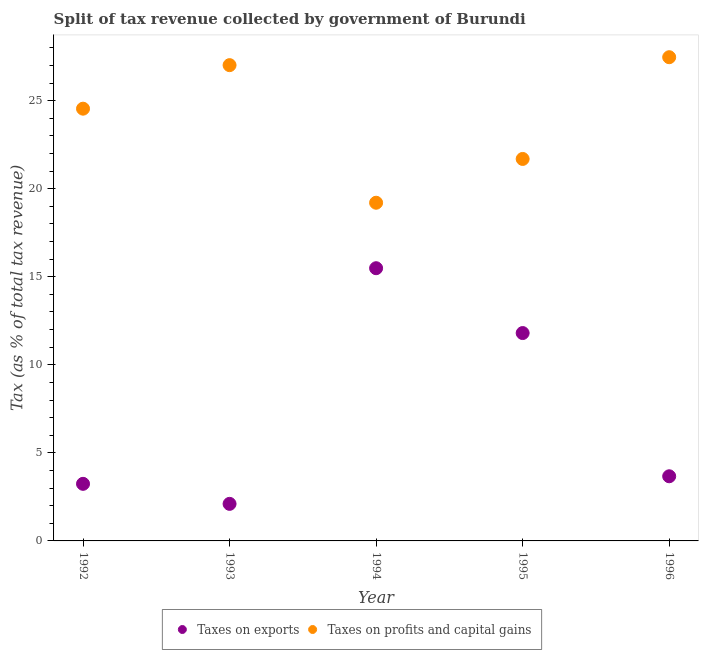How many different coloured dotlines are there?
Your response must be concise. 2. Is the number of dotlines equal to the number of legend labels?
Your response must be concise. Yes. What is the percentage of revenue obtained from taxes on profits and capital gains in 1993?
Offer a terse response. 27.02. Across all years, what is the maximum percentage of revenue obtained from taxes on exports?
Your answer should be very brief. 15.49. Across all years, what is the minimum percentage of revenue obtained from taxes on profits and capital gains?
Your response must be concise. 19.2. In which year was the percentage of revenue obtained from taxes on profits and capital gains maximum?
Provide a short and direct response. 1996. What is the total percentage of revenue obtained from taxes on profits and capital gains in the graph?
Your answer should be very brief. 119.92. What is the difference between the percentage of revenue obtained from taxes on exports in 1993 and that in 1994?
Your answer should be very brief. -13.38. What is the difference between the percentage of revenue obtained from taxes on profits and capital gains in 1994 and the percentage of revenue obtained from taxes on exports in 1993?
Keep it short and to the point. 17.1. What is the average percentage of revenue obtained from taxes on exports per year?
Give a very brief answer. 7.26. In the year 1993, what is the difference between the percentage of revenue obtained from taxes on exports and percentage of revenue obtained from taxes on profits and capital gains?
Offer a very short reply. -24.91. What is the ratio of the percentage of revenue obtained from taxes on exports in 1992 to that in 1993?
Offer a terse response. 1.54. Is the difference between the percentage of revenue obtained from taxes on exports in 1993 and 1994 greater than the difference between the percentage of revenue obtained from taxes on profits and capital gains in 1993 and 1994?
Make the answer very short. No. What is the difference between the highest and the second highest percentage of revenue obtained from taxes on exports?
Offer a very short reply. 3.68. What is the difference between the highest and the lowest percentage of revenue obtained from taxes on exports?
Make the answer very short. 13.38. Is the sum of the percentage of revenue obtained from taxes on profits and capital gains in 1993 and 1996 greater than the maximum percentage of revenue obtained from taxes on exports across all years?
Give a very brief answer. Yes. Does the percentage of revenue obtained from taxes on exports monotonically increase over the years?
Keep it short and to the point. No. Are the values on the major ticks of Y-axis written in scientific E-notation?
Your response must be concise. No. Does the graph contain any zero values?
Offer a terse response. No. Where does the legend appear in the graph?
Offer a terse response. Bottom center. How many legend labels are there?
Offer a very short reply. 2. How are the legend labels stacked?
Keep it short and to the point. Horizontal. What is the title of the graph?
Your answer should be compact. Split of tax revenue collected by government of Burundi. Does "Domestic liabilities" appear as one of the legend labels in the graph?
Keep it short and to the point. No. What is the label or title of the X-axis?
Your response must be concise. Year. What is the label or title of the Y-axis?
Provide a succinct answer. Tax (as % of total tax revenue). What is the Tax (as % of total tax revenue) in Taxes on exports in 1992?
Offer a very short reply. 3.24. What is the Tax (as % of total tax revenue) of Taxes on profits and capital gains in 1992?
Keep it short and to the point. 24.54. What is the Tax (as % of total tax revenue) of Taxes on exports in 1993?
Offer a very short reply. 2.1. What is the Tax (as % of total tax revenue) of Taxes on profits and capital gains in 1993?
Offer a very short reply. 27.02. What is the Tax (as % of total tax revenue) of Taxes on exports in 1994?
Your response must be concise. 15.49. What is the Tax (as % of total tax revenue) in Taxes on profits and capital gains in 1994?
Offer a terse response. 19.2. What is the Tax (as % of total tax revenue) in Taxes on exports in 1995?
Provide a succinct answer. 11.8. What is the Tax (as % of total tax revenue) of Taxes on profits and capital gains in 1995?
Keep it short and to the point. 21.69. What is the Tax (as % of total tax revenue) in Taxes on exports in 1996?
Offer a very short reply. 3.67. What is the Tax (as % of total tax revenue) in Taxes on profits and capital gains in 1996?
Ensure brevity in your answer.  27.47. Across all years, what is the maximum Tax (as % of total tax revenue) of Taxes on exports?
Provide a short and direct response. 15.49. Across all years, what is the maximum Tax (as % of total tax revenue) of Taxes on profits and capital gains?
Your answer should be compact. 27.47. Across all years, what is the minimum Tax (as % of total tax revenue) in Taxes on exports?
Your answer should be compact. 2.1. Across all years, what is the minimum Tax (as % of total tax revenue) of Taxes on profits and capital gains?
Offer a very short reply. 19.2. What is the total Tax (as % of total tax revenue) of Taxes on exports in the graph?
Your answer should be compact. 36.31. What is the total Tax (as % of total tax revenue) of Taxes on profits and capital gains in the graph?
Your answer should be compact. 119.92. What is the difference between the Tax (as % of total tax revenue) in Taxes on exports in 1992 and that in 1993?
Your response must be concise. 1.14. What is the difference between the Tax (as % of total tax revenue) of Taxes on profits and capital gains in 1992 and that in 1993?
Ensure brevity in your answer.  -2.47. What is the difference between the Tax (as % of total tax revenue) in Taxes on exports in 1992 and that in 1994?
Offer a terse response. -12.24. What is the difference between the Tax (as % of total tax revenue) of Taxes on profits and capital gains in 1992 and that in 1994?
Offer a terse response. 5.34. What is the difference between the Tax (as % of total tax revenue) in Taxes on exports in 1992 and that in 1995?
Your answer should be very brief. -8.56. What is the difference between the Tax (as % of total tax revenue) of Taxes on profits and capital gains in 1992 and that in 1995?
Offer a very short reply. 2.85. What is the difference between the Tax (as % of total tax revenue) of Taxes on exports in 1992 and that in 1996?
Keep it short and to the point. -0.43. What is the difference between the Tax (as % of total tax revenue) of Taxes on profits and capital gains in 1992 and that in 1996?
Provide a succinct answer. -2.92. What is the difference between the Tax (as % of total tax revenue) in Taxes on exports in 1993 and that in 1994?
Offer a terse response. -13.38. What is the difference between the Tax (as % of total tax revenue) of Taxes on profits and capital gains in 1993 and that in 1994?
Give a very brief answer. 7.81. What is the difference between the Tax (as % of total tax revenue) of Taxes on exports in 1993 and that in 1995?
Keep it short and to the point. -9.7. What is the difference between the Tax (as % of total tax revenue) in Taxes on profits and capital gains in 1993 and that in 1995?
Your answer should be compact. 5.33. What is the difference between the Tax (as % of total tax revenue) in Taxes on exports in 1993 and that in 1996?
Your answer should be very brief. -1.57. What is the difference between the Tax (as % of total tax revenue) of Taxes on profits and capital gains in 1993 and that in 1996?
Keep it short and to the point. -0.45. What is the difference between the Tax (as % of total tax revenue) of Taxes on exports in 1994 and that in 1995?
Your response must be concise. 3.68. What is the difference between the Tax (as % of total tax revenue) of Taxes on profits and capital gains in 1994 and that in 1995?
Make the answer very short. -2.49. What is the difference between the Tax (as % of total tax revenue) in Taxes on exports in 1994 and that in 1996?
Your answer should be compact. 11.81. What is the difference between the Tax (as % of total tax revenue) in Taxes on profits and capital gains in 1994 and that in 1996?
Your answer should be compact. -8.26. What is the difference between the Tax (as % of total tax revenue) in Taxes on exports in 1995 and that in 1996?
Keep it short and to the point. 8.13. What is the difference between the Tax (as % of total tax revenue) in Taxes on profits and capital gains in 1995 and that in 1996?
Provide a succinct answer. -5.78. What is the difference between the Tax (as % of total tax revenue) of Taxes on exports in 1992 and the Tax (as % of total tax revenue) of Taxes on profits and capital gains in 1993?
Your answer should be compact. -23.78. What is the difference between the Tax (as % of total tax revenue) of Taxes on exports in 1992 and the Tax (as % of total tax revenue) of Taxes on profits and capital gains in 1994?
Provide a succinct answer. -15.96. What is the difference between the Tax (as % of total tax revenue) of Taxes on exports in 1992 and the Tax (as % of total tax revenue) of Taxes on profits and capital gains in 1995?
Your response must be concise. -18.45. What is the difference between the Tax (as % of total tax revenue) of Taxes on exports in 1992 and the Tax (as % of total tax revenue) of Taxes on profits and capital gains in 1996?
Provide a succinct answer. -24.23. What is the difference between the Tax (as % of total tax revenue) of Taxes on exports in 1993 and the Tax (as % of total tax revenue) of Taxes on profits and capital gains in 1994?
Keep it short and to the point. -17.1. What is the difference between the Tax (as % of total tax revenue) of Taxes on exports in 1993 and the Tax (as % of total tax revenue) of Taxes on profits and capital gains in 1995?
Your answer should be compact. -19.59. What is the difference between the Tax (as % of total tax revenue) in Taxes on exports in 1993 and the Tax (as % of total tax revenue) in Taxes on profits and capital gains in 1996?
Your answer should be compact. -25.36. What is the difference between the Tax (as % of total tax revenue) in Taxes on exports in 1994 and the Tax (as % of total tax revenue) in Taxes on profits and capital gains in 1995?
Ensure brevity in your answer.  -6.2. What is the difference between the Tax (as % of total tax revenue) in Taxes on exports in 1994 and the Tax (as % of total tax revenue) in Taxes on profits and capital gains in 1996?
Provide a succinct answer. -11.98. What is the difference between the Tax (as % of total tax revenue) in Taxes on exports in 1995 and the Tax (as % of total tax revenue) in Taxes on profits and capital gains in 1996?
Your response must be concise. -15.66. What is the average Tax (as % of total tax revenue) in Taxes on exports per year?
Ensure brevity in your answer.  7.26. What is the average Tax (as % of total tax revenue) of Taxes on profits and capital gains per year?
Make the answer very short. 23.98. In the year 1992, what is the difference between the Tax (as % of total tax revenue) of Taxes on exports and Tax (as % of total tax revenue) of Taxes on profits and capital gains?
Ensure brevity in your answer.  -21.3. In the year 1993, what is the difference between the Tax (as % of total tax revenue) in Taxes on exports and Tax (as % of total tax revenue) in Taxes on profits and capital gains?
Your response must be concise. -24.91. In the year 1994, what is the difference between the Tax (as % of total tax revenue) in Taxes on exports and Tax (as % of total tax revenue) in Taxes on profits and capital gains?
Your response must be concise. -3.72. In the year 1995, what is the difference between the Tax (as % of total tax revenue) in Taxes on exports and Tax (as % of total tax revenue) in Taxes on profits and capital gains?
Provide a short and direct response. -9.89. In the year 1996, what is the difference between the Tax (as % of total tax revenue) of Taxes on exports and Tax (as % of total tax revenue) of Taxes on profits and capital gains?
Provide a succinct answer. -23.8. What is the ratio of the Tax (as % of total tax revenue) of Taxes on exports in 1992 to that in 1993?
Your response must be concise. 1.54. What is the ratio of the Tax (as % of total tax revenue) of Taxes on profits and capital gains in 1992 to that in 1993?
Give a very brief answer. 0.91. What is the ratio of the Tax (as % of total tax revenue) in Taxes on exports in 1992 to that in 1994?
Make the answer very short. 0.21. What is the ratio of the Tax (as % of total tax revenue) of Taxes on profits and capital gains in 1992 to that in 1994?
Make the answer very short. 1.28. What is the ratio of the Tax (as % of total tax revenue) in Taxes on exports in 1992 to that in 1995?
Provide a short and direct response. 0.27. What is the ratio of the Tax (as % of total tax revenue) in Taxes on profits and capital gains in 1992 to that in 1995?
Provide a succinct answer. 1.13. What is the ratio of the Tax (as % of total tax revenue) of Taxes on exports in 1992 to that in 1996?
Ensure brevity in your answer.  0.88. What is the ratio of the Tax (as % of total tax revenue) in Taxes on profits and capital gains in 1992 to that in 1996?
Your answer should be compact. 0.89. What is the ratio of the Tax (as % of total tax revenue) in Taxes on exports in 1993 to that in 1994?
Offer a terse response. 0.14. What is the ratio of the Tax (as % of total tax revenue) of Taxes on profits and capital gains in 1993 to that in 1994?
Keep it short and to the point. 1.41. What is the ratio of the Tax (as % of total tax revenue) in Taxes on exports in 1993 to that in 1995?
Offer a very short reply. 0.18. What is the ratio of the Tax (as % of total tax revenue) of Taxes on profits and capital gains in 1993 to that in 1995?
Your answer should be compact. 1.25. What is the ratio of the Tax (as % of total tax revenue) in Taxes on exports in 1993 to that in 1996?
Provide a short and direct response. 0.57. What is the ratio of the Tax (as % of total tax revenue) in Taxes on profits and capital gains in 1993 to that in 1996?
Your answer should be very brief. 0.98. What is the ratio of the Tax (as % of total tax revenue) of Taxes on exports in 1994 to that in 1995?
Provide a succinct answer. 1.31. What is the ratio of the Tax (as % of total tax revenue) of Taxes on profits and capital gains in 1994 to that in 1995?
Make the answer very short. 0.89. What is the ratio of the Tax (as % of total tax revenue) in Taxes on exports in 1994 to that in 1996?
Ensure brevity in your answer.  4.22. What is the ratio of the Tax (as % of total tax revenue) in Taxes on profits and capital gains in 1994 to that in 1996?
Ensure brevity in your answer.  0.7. What is the ratio of the Tax (as % of total tax revenue) in Taxes on exports in 1995 to that in 1996?
Your answer should be very brief. 3.22. What is the ratio of the Tax (as % of total tax revenue) of Taxes on profits and capital gains in 1995 to that in 1996?
Ensure brevity in your answer.  0.79. What is the difference between the highest and the second highest Tax (as % of total tax revenue) in Taxes on exports?
Ensure brevity in your answer.  3.68. What is the difference between the highest and the second highest Tax (as % of total tax revenue) of Taxes on profits and capital gains?
Your response must be concise. 0.45. What is the difference between the highest and the lowest Tax (as % of total tax revenue) in Taxes on exports?
Keep it short and to the point. 13.38. What is the difference between the highest and the lowest Tax (as % of total tax revenue) of Taxes on profits and capital gains?
Provide a short and direct response. 8.26. 